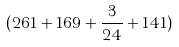<formula> <loc_0><loc_0><loc_500><loc_500>( 2 6 1 + 1 6 9 + \frac { 3 } { 2 4 } + 1 4 1 )</formula> 